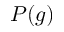Convert formula to latex. <formula><loc_0><loc_0><loc_500><loc_500>P ( g )</formula> 